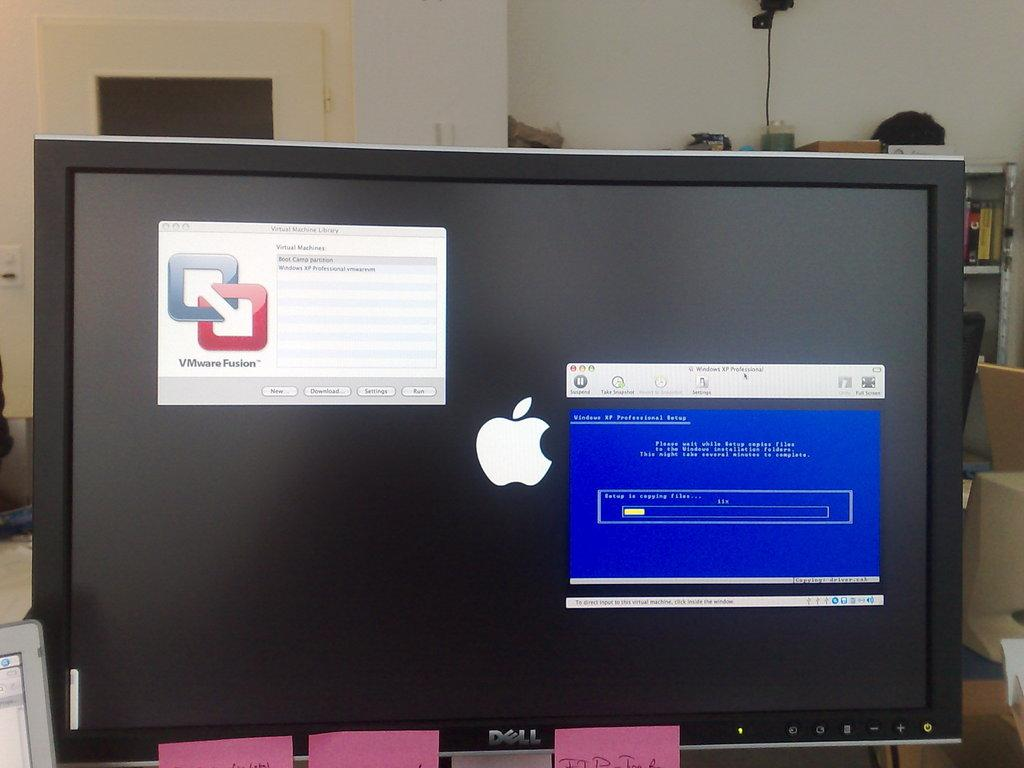Provide a one-sentence caption for the provided image. A Dell computer monitor is covered in sticky notes. 